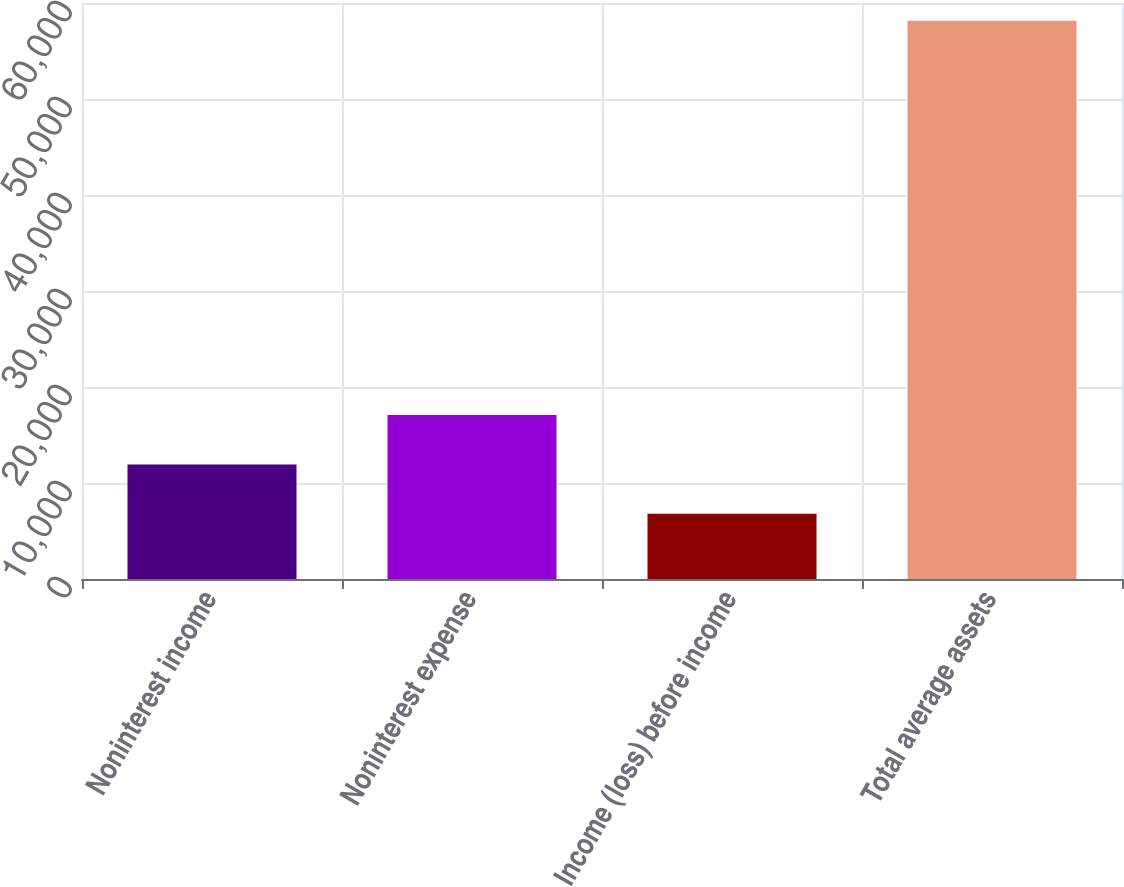<chart> <loc_0><loc_0><loc_500><loc_500><bar_chart><fcel>Noninterest income<fcel>Noninterest expense<fcel>Income (loss) before income<fcel>Total average assets<nl><fcel>11938.1<fcel>17072.2<fcel>6804<fcel>58145<nl></chart> 